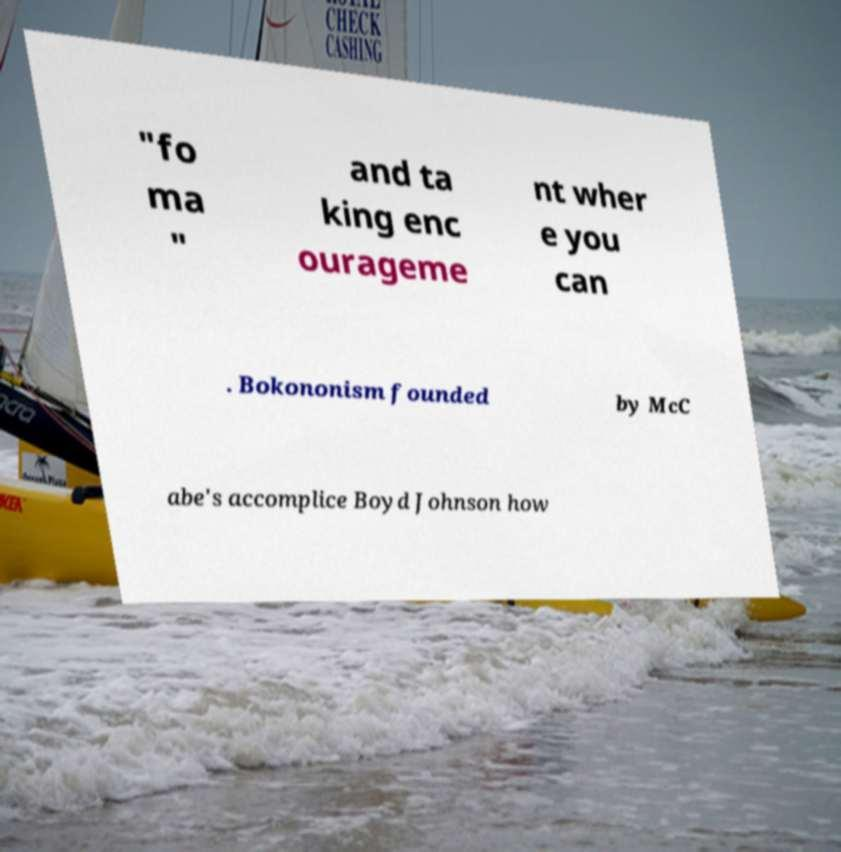Could you assist in decoding the text presented in this image and type it out clearly? "fo ma " and ta king enc ourageme nt wher e you can . Bokononism founded by McC abe's accomplice Boyd Johnson how 